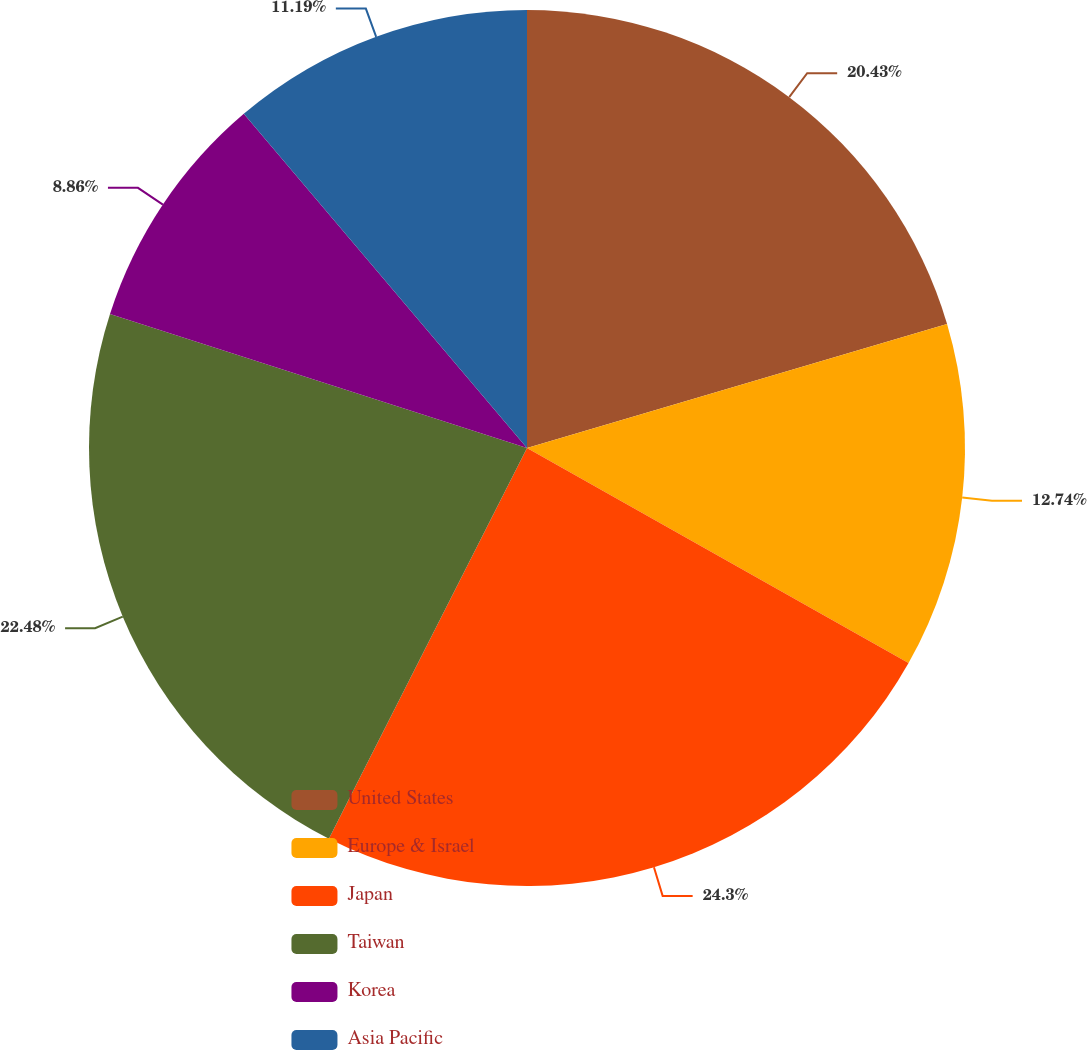<chart> <loc_0><loc_0><loc_500><loc_500><pie_chart><fcel>United States<fcel>Europe & Israel<fcel>Japan<fcel>Taiwan<fcel>Korea<fcel>Asia Pacific<nl><fcel>20.43%<fcel>12.74%<fcel>24.3%<fcel>22.48%<fcel>8.86%<fcel>11.19%<nl></chart> 